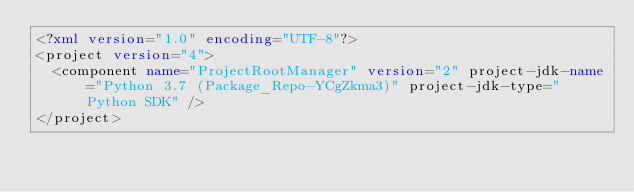Convert code to text. <code><loc_0><loc_0><loc_500><loc_500><_XML_><?xml version="1.0" encoding="UTF-8"?>
<project version="4">
  <component name="ProjectRootManager" version="2" project-jdk-name="Python 3.7 (Package_Repo-YCgZkma3)" project-jdk-type="Python SDK" />
</project></code> 